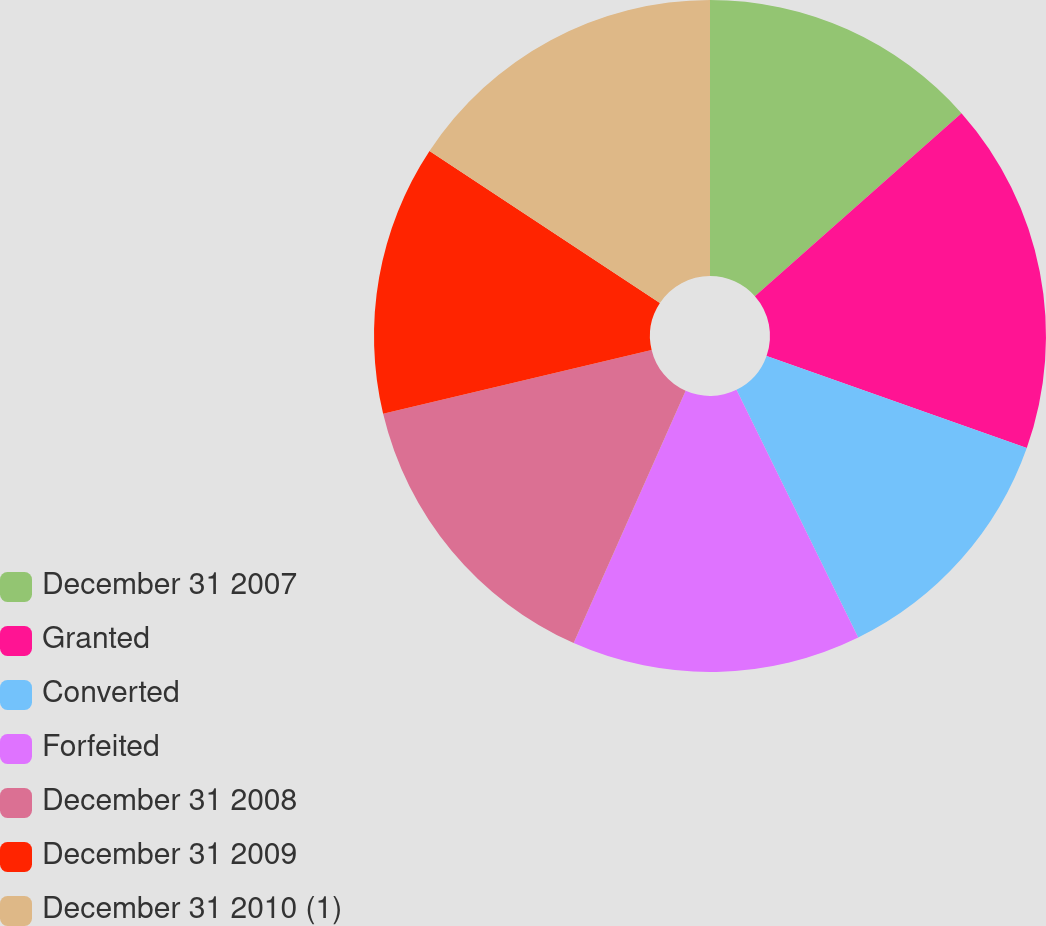Convert chart. <chart><loc_0><loc_0><loc_500><loc_500><pie_chart><fcel>December 31 2007<fcel>Granted<fcel>Converted<fcel>Forfeited<fcel>December 31 2008<fcel>December 31 2009<fcel>December 31 2010 (1)<nl><fcel>13.46%<fcel>16.95%<fcel>12.32%<fcel>13.92%<fcel>14.63%<fcel>13.0%<fcel>15.72%<nl></chart> 